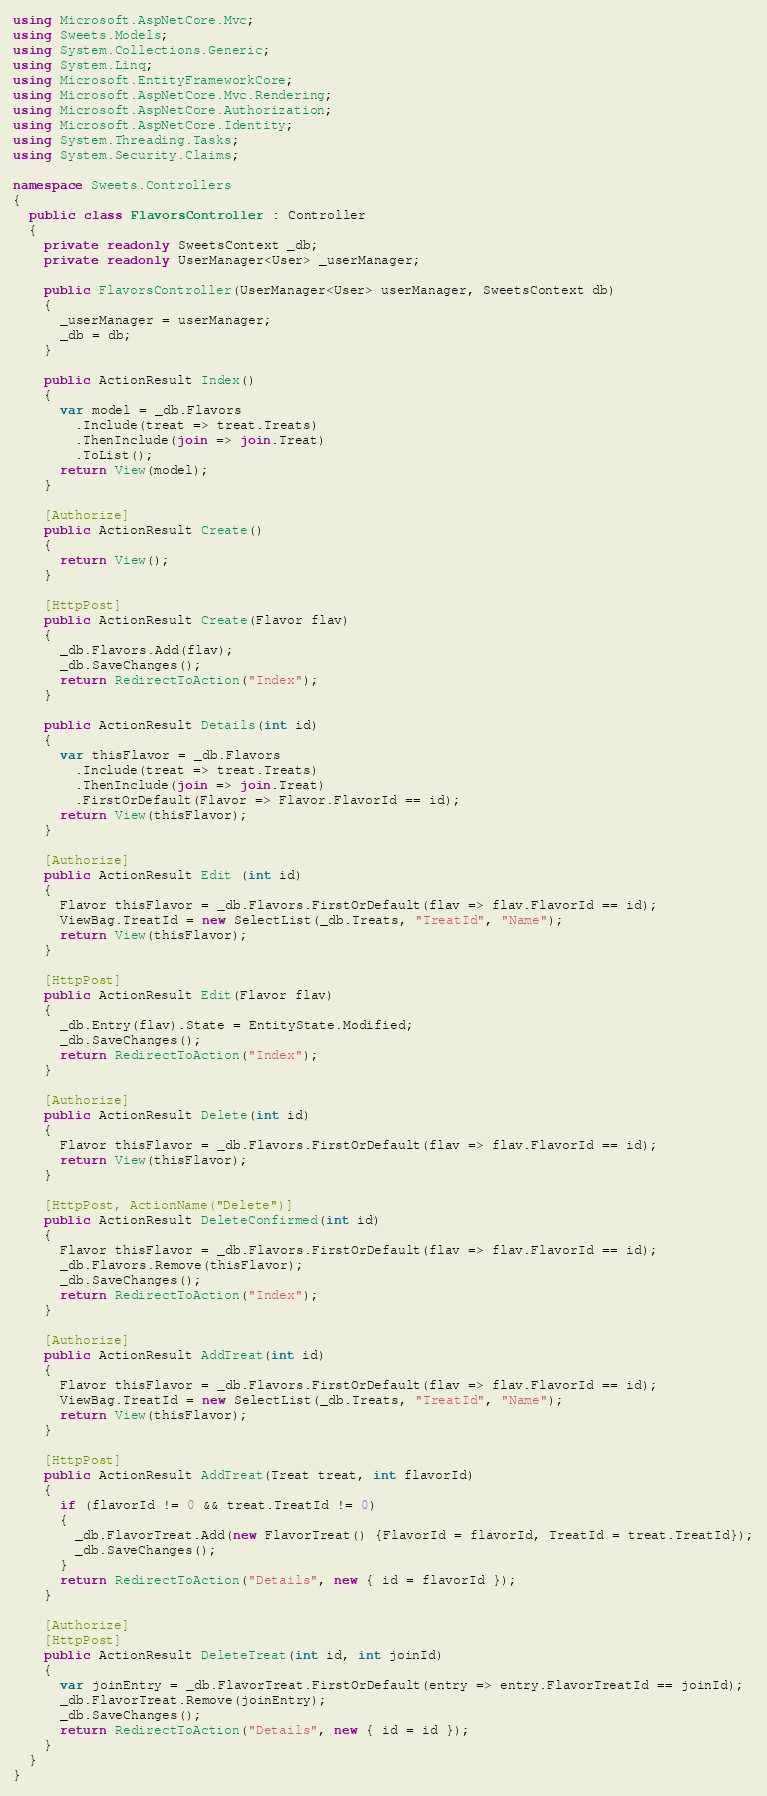<code> <loc_0><loc_0><loc_500><loc_500><_C#_>using Microsoft.AspNetCore.Mvc;
using Sweets.Models;
using System.Collections.Generic;
using System.Linq;
using Microsoft.EntityFrameworkCore;
using Microsoft.AspNetCore.Mvc.Rendering;
using Microsoft.AspNetCore.Authorization;
using Microsoft.AspNetCore.Identity;
using System.Threading.Tasks;
using System.Security.Claims;

namespace Sweets.Controllers
{
  public class FlavorsController : Controller
  {
    private readonly SweetsContext _db;
    private readonly UserManager<User> _userManager;

    public FlavorsController(UserManager<User> userManager, SweetsContext db)
    {
      _userManager = userManager;
      _db = db;
    }

    public ActionResult Index()
    {
      var model = _db.Flavors
        .Include(treat => treat.Treats)
        .ThenInclude(join => join.Treat)
        .ToList();
      return View(model);
    }

    [Authorize] 
    public ActionResult Create()
    {
      return View();
    }

    [HttpPost]
    public ActionResult Create(Flavor flav)
    {
      _db.Flavors.Add(flav);
      _db.SaveChanges();
      return RedirectToAction("Index");
    }

    public ActionResult Details(int id)
    {
      var thisFlavor = _db.Flavors
        .Include(treat => treat.Treats)
        .ThenInclude(join => join.Treat)
        .FirstOrDefault(Flavor => Flavor.FlavorId == id);
      return View(thisFlavor);
    }

    [Authorize] 
    public ActionResult Edit (int id)
    {
      Flavor thisFlavor = _db.Flavors.FirstOrDefault(flav => flav.FlavorId == id);
      ViewBag.TreatId = new SelectList(_db.Treats, "TreatId", "Name");
      return View(thisFlavor);
    }

    [HttpPost]
    public ActionResult Edit(Flavor flav)
    {
      _db.Entry(flav).State = EntityState.Modified; 
      _db.SaveChanges();
      return RedirectToAction("Index");
    }

    [Authorize] 
    public ActionResult Delete(int id)
    {
      Flavor thisFlavor = _db.Flavors.FirstOrDefault(flav => flav.FlavorId == id);
      return View(thisFlavor);
    }

    [HttpPost, ActionName("Delete")]
    public ActionResult DeleteConfirmed(int id)
    { 
      Flavor thisFlavor = _db.Flavors.FirstOrDefault(flav => flav.FlavorId == id);
      _db.Flavors.Remove(thisFlavor);
      _db.SaveChanges();
      return RedirectToAction("Index");
    }

    [Authorize] 
    public ActionResult AddTreat(int id)
    {
      Flavor thisFlavor = _db.Flavors.FirstOrDefault(flav => flav.FlavorId == id);
      ViewBag.TreatId = new SelectList(_db.Treats, "TreatId", "Name");
      return View(thisFlavor);
    }

    [HttpPost]
    public ActionResult AddTreat(Treat treat, int flavorId)
    {
      if (flavorId != 0 && treat.TreatId != 0)
      {
        _db.FlavorTreat.Add(new FlavorTreat() {FlavorId = flavorId, TreatId = treat.TreatId});
        _db.SaveChanges();
      }
      return RedirectToAction("Details", new { id = flavorId });
    }

    [Authorize] 
    [HttpPost]
    public ActionResult DeleteTreat(int id, int joinId)
    {
      var joinEntry = _db.FlavorTreat.FirstOrDefault(entry => entry.FlavorTreatId == joinId);
      _db.FlavorTreat.Remove(joinEntry);
      _db.SaveChanges();
      return RedirectToAction("Details", new { id = id });
    }
  }
}</code> 